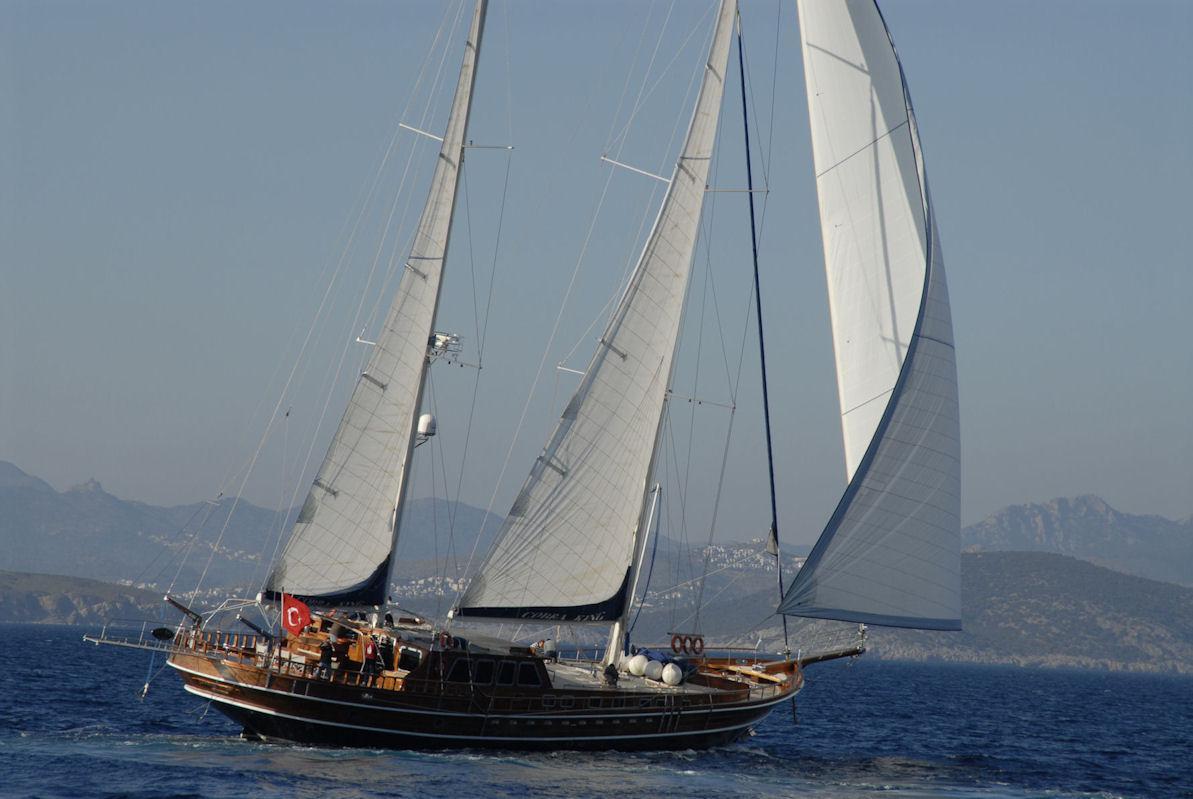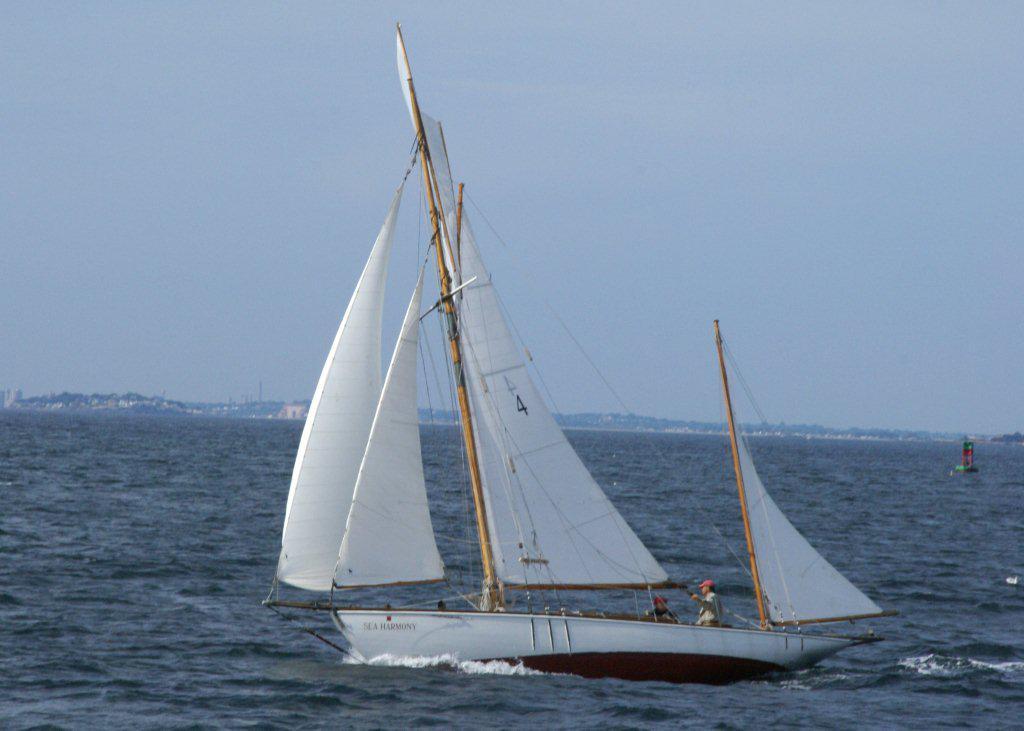The first image is the image on the left, the second image is the image on the right. Analyze the images presented: Is the assertion "One sailboat is on the open water with its sails folded down." valid? Answer yes or no. No. The first image is the image on the left, the second image is the image on the right. Considering the images on both sides, is "The left and right image contains the same number of sailboats sailing with at least one with no sails out." valid? Answer yes or no. No. 